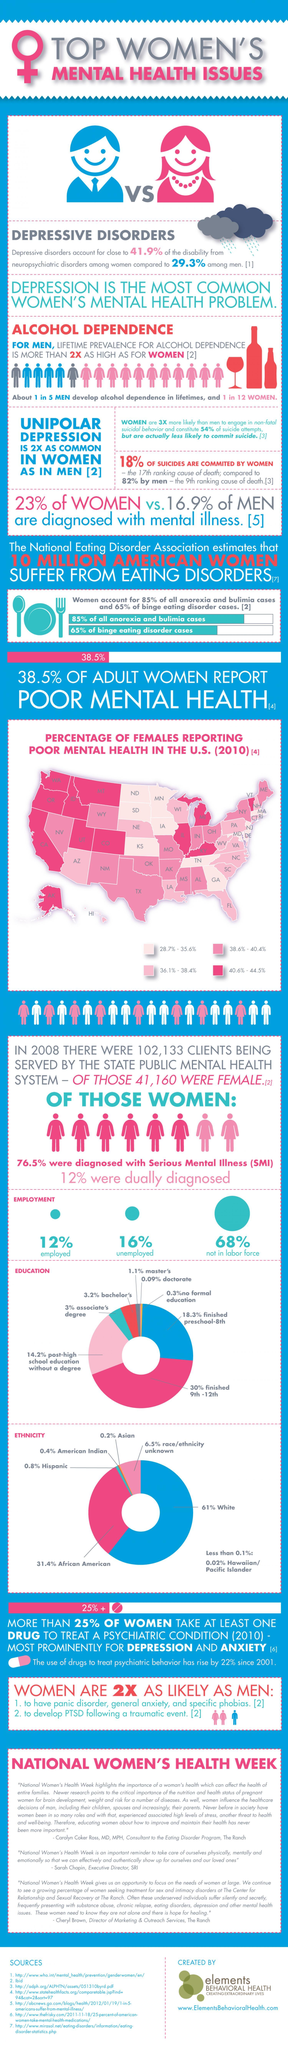What percentage of women are unemployed?
Answer the question with a short phrase. 16% How many states in the U.S  reported with females of poor mental health 40.6%-44.5%? 13 Out of 102,133 clients in the state public mental health system, how many are males? 60973 What percentage of women are employed? 12% What percentage of women not suffered from binge eating disorder cases? 35% What percentage of women are not in the labor force? 68% What percentage of women have a master's and doctorate, taken together? 1.19% What percentage of men are not diagnosed with mental illness? 83.1% What percentage of adult women not reported poor mental health? 61.5% What percentage of women not suffered from anorexia and bulimia cases? 15% What percentage of suicides are not committed by women? 82% What percentage of women have a bachelor's and associate's degree, taken together? 6.2% What percentage of women are not diagnosed with mental illness? 77% 